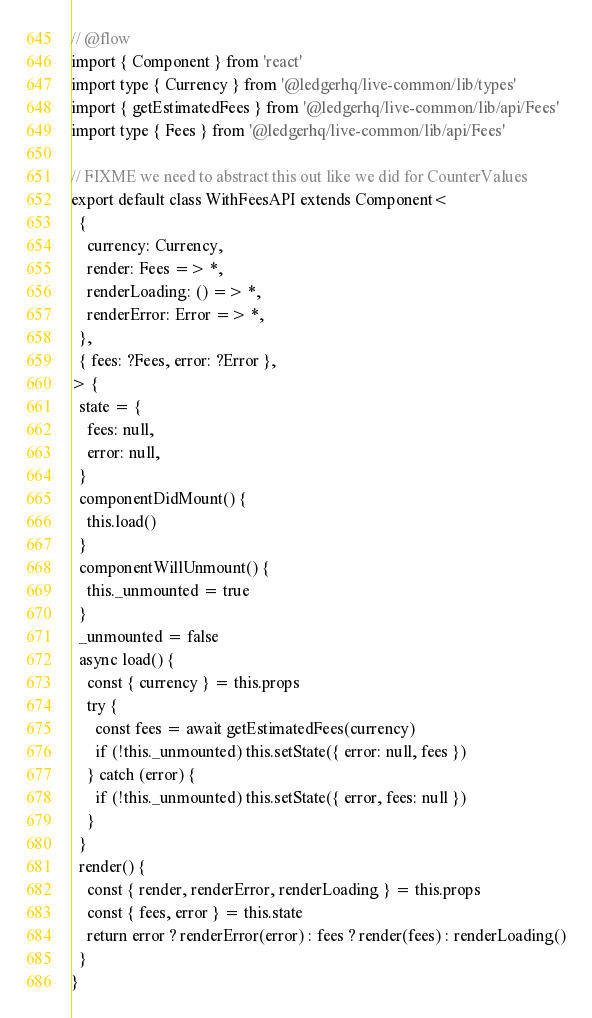Convert code to text. <code><loc_0><loc_0><loc_500><loc_500><_JavaScript_>// @flow
import { Component } from 'react'
import type { Currency } from '@ledgerhq/live-common/lib/types'
import { getEstimatedFees } from '@ledgerhq/live-common/lib/api/Fees'
import type { Fees } from '@ledgerhq/live-common/lib/api/Fees'

// FIXME we need to abstract this out like we did for CounterValues
export default class WithFeesAPI extends Component<
  {
    currency: Currency,
    render: Fees => *,
    renderLoading: () => *,
    renderError: Error => *,
  },
  { fees: ?Fees, error: ?Error },
> {
  state = {
    fees: null,
    error: null,
  }
  componentDidMount() {
    this.load()
  }
  componentWillUnmount() {
    this._unmounted = true
  }
  _unmounted = false
  async load() {
    const { currency } = this.props
    try {
      const fees = await getEstimatedFees(currency)
      if (!this._unmounted) this.setState({ error: null, fees })
    } catch (error) {
      if (!this._unmounted) this.setState({ error, fees: null })
    }
  }
  render() {
    const { render, renderError, renderLoading } = this.props
    const { fees, error } = this.state
    return error ? renderError(error) : fees ? render(fees) : renderLoading()
  }
}
</code> 